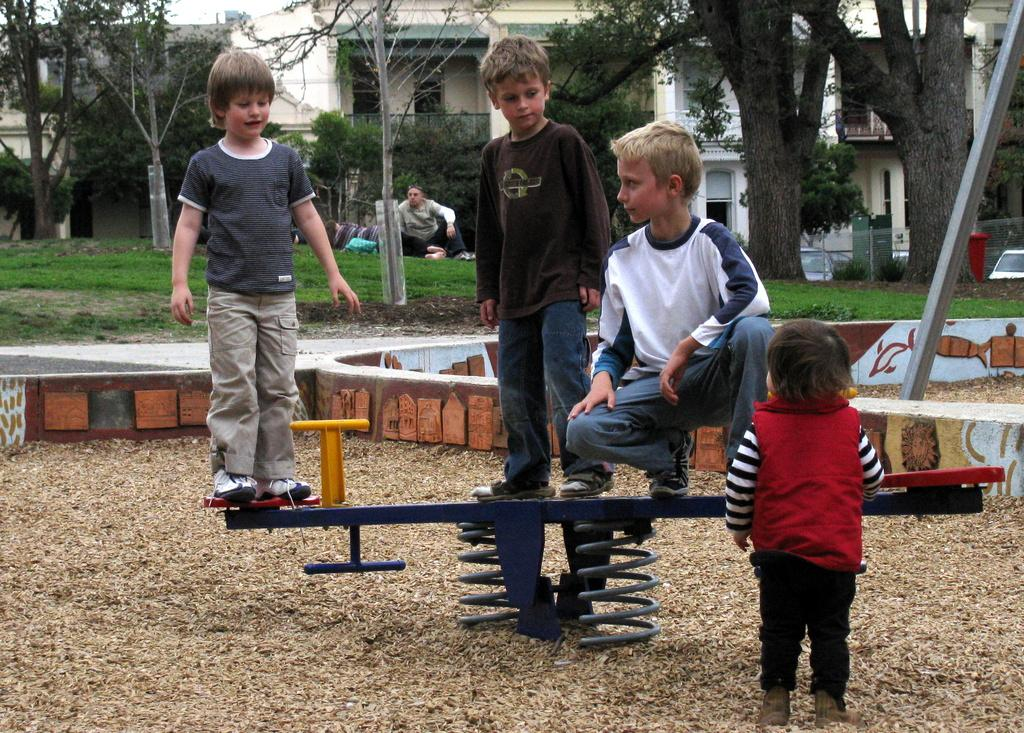What can be seen in the background of the image? There are buildings, trees, and vehicles in the background of the image. What is the person in the image doing? The person is sitting on the grass. How many kids are in the image? There are four kids in the image. What type of playground equipment is present in the image? There is a seesaw in the image. What type of spot does the person have on their face in the image? There is no mention of a spot on the person's face in the image. What decision did the kids make before playing on the seesaw? The provided facts do not mention any decisions made by the kids before playing on the seesaw. 